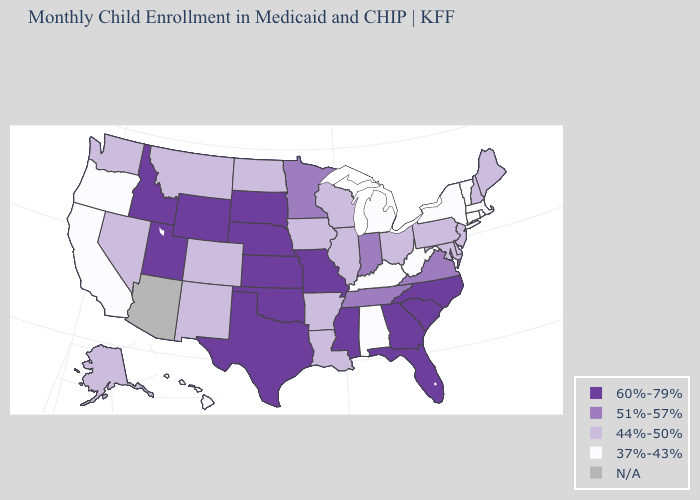What is the value of North Carolina?
Give a very brief answer. 60%-79%. Name the states that have a value in the range 60%-79%?
Quick response, please. Florida, Georgia, Idaho, Kansas, Mississippi, Missouri, Nebraska, North Carolina, Oklahoma, South Carolina, South Dakota, Texas, Utah, Wyoming. What is the value of Minnesota?
Quick response, please. 51%-57%. Which states have the lowest value in the USA?
Keep it brief. Alabama, California, Connecticut, Hawaii, Kentucky, Massachusetts, Michigan, New York, Oregon, Rhode Island, Vermont, West Virginia. Among the states that border California , does Oregon have the lowest value?
Be succinct. Yes. What is the lowest value in the South?
Short answer required. 37%-43%. What is the value of Arizona?
Be succinct. N/A. What is the highest value in states that border Utah?
Answer briefly. 60%-79%. What is the value of Montana?
Quick response, please. 44%-50%. Among the states that border Louisiana , does Texas have the highest value?
Short answer required. Yes. Does New Mexico have the highest value in the West?
Answer briefly. No. Name the states that have a value in the range N/A?
Keep it brief. Arizona. Which states have the lowest value in the Northeast?
Write a very short answer. Connecticut, Massachusetts, New York, Rhode Island, Vermont. Does Michigan have the lowest value in the MidWest?
Concise answer only. Yes. 